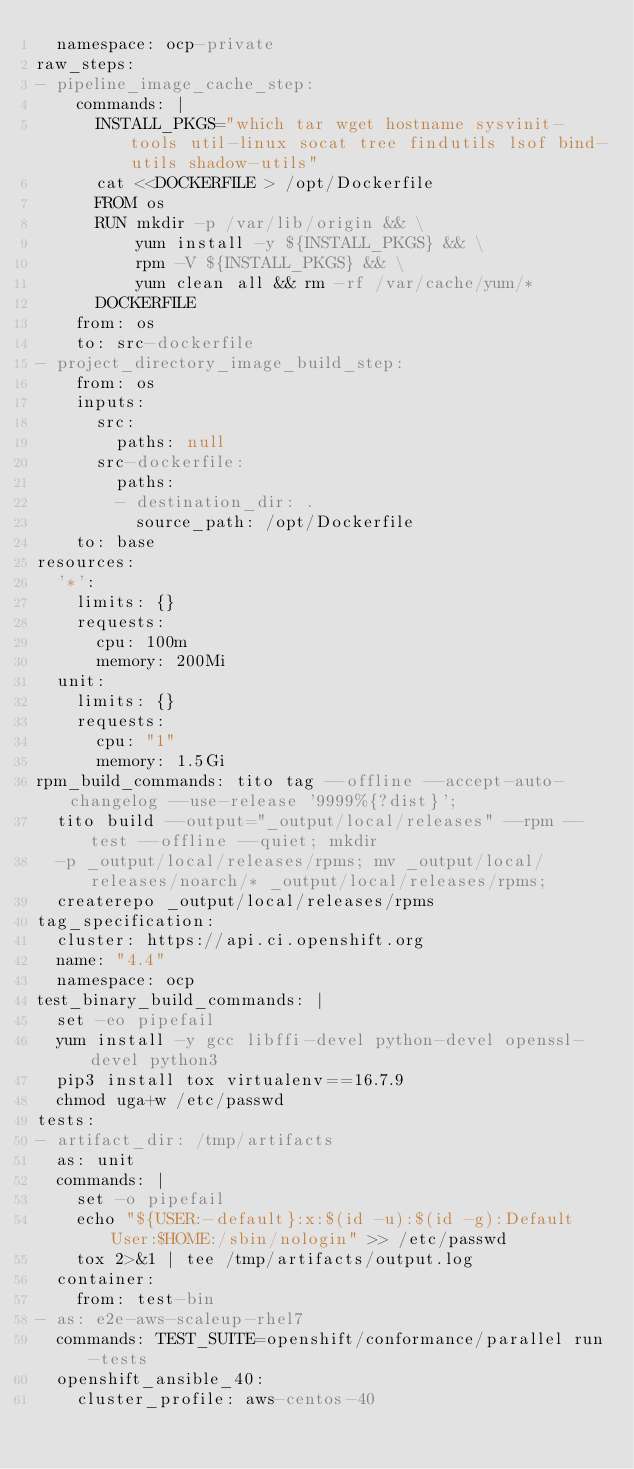<code> <loc_0><loc_0><loc_500><loc_500><_YAML_>  namespace: ocp-private
raw_steps:
- pipeline_image_cache_step:
    commands: |
      INSTALL_PKGS="which tar wget hostname sysvinit-tools util-linux socat tree findutils lsof bind-utils shadow-utils"
      cat <<DOCKERFILE > /opt/Dockerfile
      FROM os
      RUN mkdir -p /var/lib/origin && \
          yum install -y ${INSTALL_PKGS} && \
          rpm -V ${INSTALL_PKGS} && \
          yum clean all && rm -rf /var/cache/yum/*
      DOCKERFILE
    from: os
    to: src-dockerfile
- project_directory_image_build_step:
    from: os
    inputs:
      src:
        paths: null
      src-dockerfile:
        paths:
        - destination_dir: .
          source_path: /opt/Dockerfile
    to: base
resources:
  '*':
    limits: {}
    requests:
      cpu: 100m
      memory: 200Mi
  unit:
    limits: {}
    requests:
      cpu: "1"
      memory: 1.5Gi
rpm_build_commands: tito tag --offline --accept-auto-changelog --use-release '9999%{?dist}';
  tito build --output="_output/local/releases" --rpm --test --offline --quiet; mkdir
  -p _output/local/releases/rpms; mv _output/local/releases/noarch/* _output/local/releases/rpms;
  createrepo _output/local/releases/rpms
tag_specification:
  cluster: https://api.ci.openshift.org
  name: "4.4"
  namespace: ocp
test_binary_build_commands: |
  set -eo pipefail
  yum install -y gcc libffi-devel python-devel openssl-devel python3
  pip3 install tox virtualenv==16.7.9
  chmod uga+w /etc/passwd
tests:
- artifact_dir: /tmp/artifacts
  as: unit
  commands: |
    set -o pipefail
    echo "${USER:-default}:x:$(id -u):$(id -g):Default User:$HOME:/sbin/nologin" >> /etc/passwd
    tox 2>&1 | tee /tmp/artifacts/output.log
  container:
    from: test-bin
- as: e2e-aws-scaleup-rhel7
  commands: TEST_SUITE=openshift/conformance/parallel run-tests
  openshift_ansible_40:
    cluster_profile: aws-centos-40
</code> 